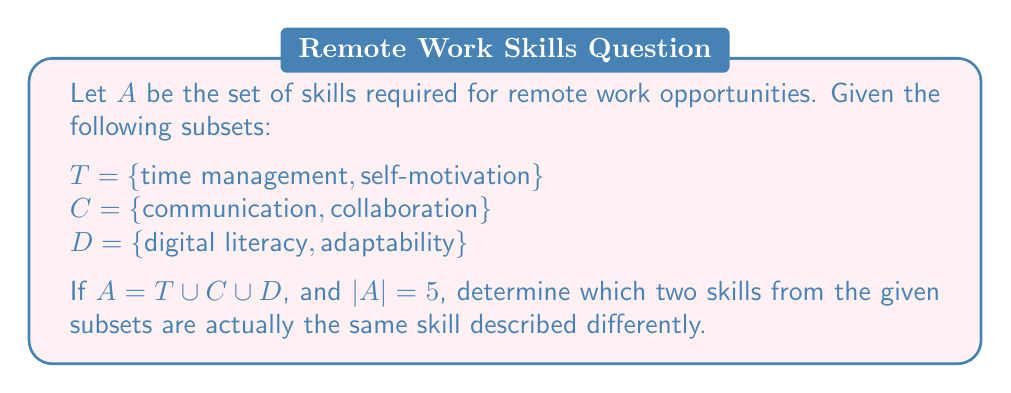Give your solution to this math problem. To solve this problem, we need to follow these steps:

1) First, let's list out all the skills from the given subsets:
   $T \cup C \cup D = \{\text{time management}, \text{self-motivation}, \text{communication}, \text{collaboration}, \text{digital literacy}, \text{adaptability}\}$

2) If all these skills were distinct, we would have $|A| = 6$. However, we're given that $|A| = 5$, which means two of these skills must be equivalent.

3) To determine which two skills are the same, we need to consider which skills might be described differently but essentially represent the same capability in a remote work context.

4) Among the given skills, "self-motivation" and "adaptability" are closely related in a remote work environment. Self-motivated individuals are often adaptable, and adaptable individuals typically need to be self-motivated to succeed in changing circumstances.

5) Therefore, we can conclude that "self-motivation" and "adaptability" are likely the same skill described differently in this context.

6) This gives us:
   $A = \{\text{time management}, \text{self-motivation/adaptability}, \text{communication}, \text{collaboration}, \text{digital literacy}\}$

7) We can verify that $|A| = 5$, which matches the given condition.
Answer: The two skills that are actually the same skill described differently are self-motivation and adaptability. 